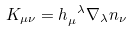<formula> <loc_0><loc_0><loc_500><loc_500>K _ { \mu \nu } = h _ { \mu } ^ { \ \lambda } \nabla _ { \lambda } n _ { \nu }</formula> 